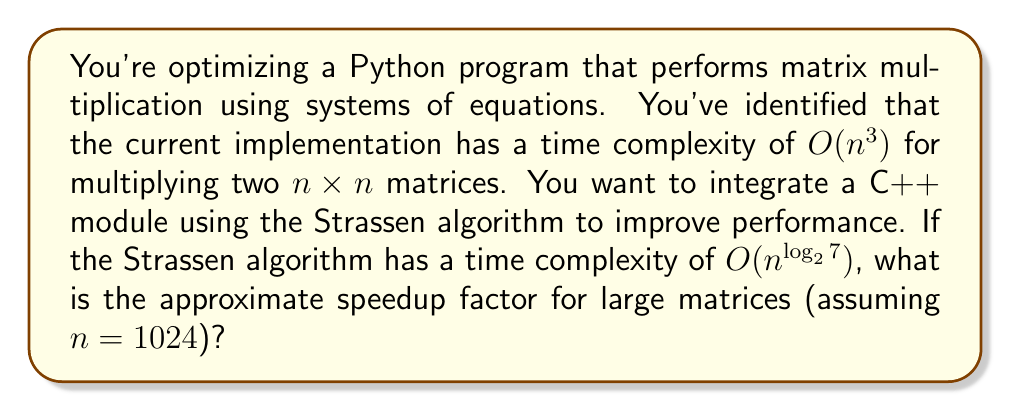Give your solution to this math problem. To solve this problem, we need to compare the time complexities of the standard matrix multiplication algorithm and the Strassen algorithm:

1. Standard algorithm: $O(n^3)$
2. Strassen algorithm: $O(n^{\log_2 7})$

Let's calculate the ratio of these complexities for $n = 1024$:

$$\text{Speedup factor} = \frac{O(n^3)}{O(n^{\log_2 7})} = \frac{n^3}{n^{\log_2 7}}$$

Now, let's calculate $\log_2 7$:

$$\log_2 7 \approx 2.807354922057604$$

Substituting $n = 1024$ and $\log_2 7$:

$$\frac{1024^3}{1024^{2.807354922057604}} = \frac{1024^3}{1024^{2.807354922057604}} = 1024^{3 - 2.807354922057604} = 1024^{0.192645077942396}$$

Using a calculator or Python to compute this value:

$$1024^{0.192645077942396} \approx 5.079$$

This means that for large matrices (n = 1024), the Strassen algorithm is approximately 5.079 times faster than the standard algorithm.

Note: The actual speedup may vary in practice due to factors such as constant factors, memory access patterns, and implementation details. However, this theoretical speedup provides a good estimate of the potential performance gain.
Answer: The approximate speedup factor for large matrices (n = 1024) is 5.079. 